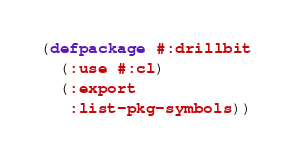Convert code to text. <code><loc_0><loc_0><loc_500><loc_500><_Lisp_>(defpackage #:drillbit
  (:use #:cl)
  (:export
   :list-pkg-symbols))
</code> 